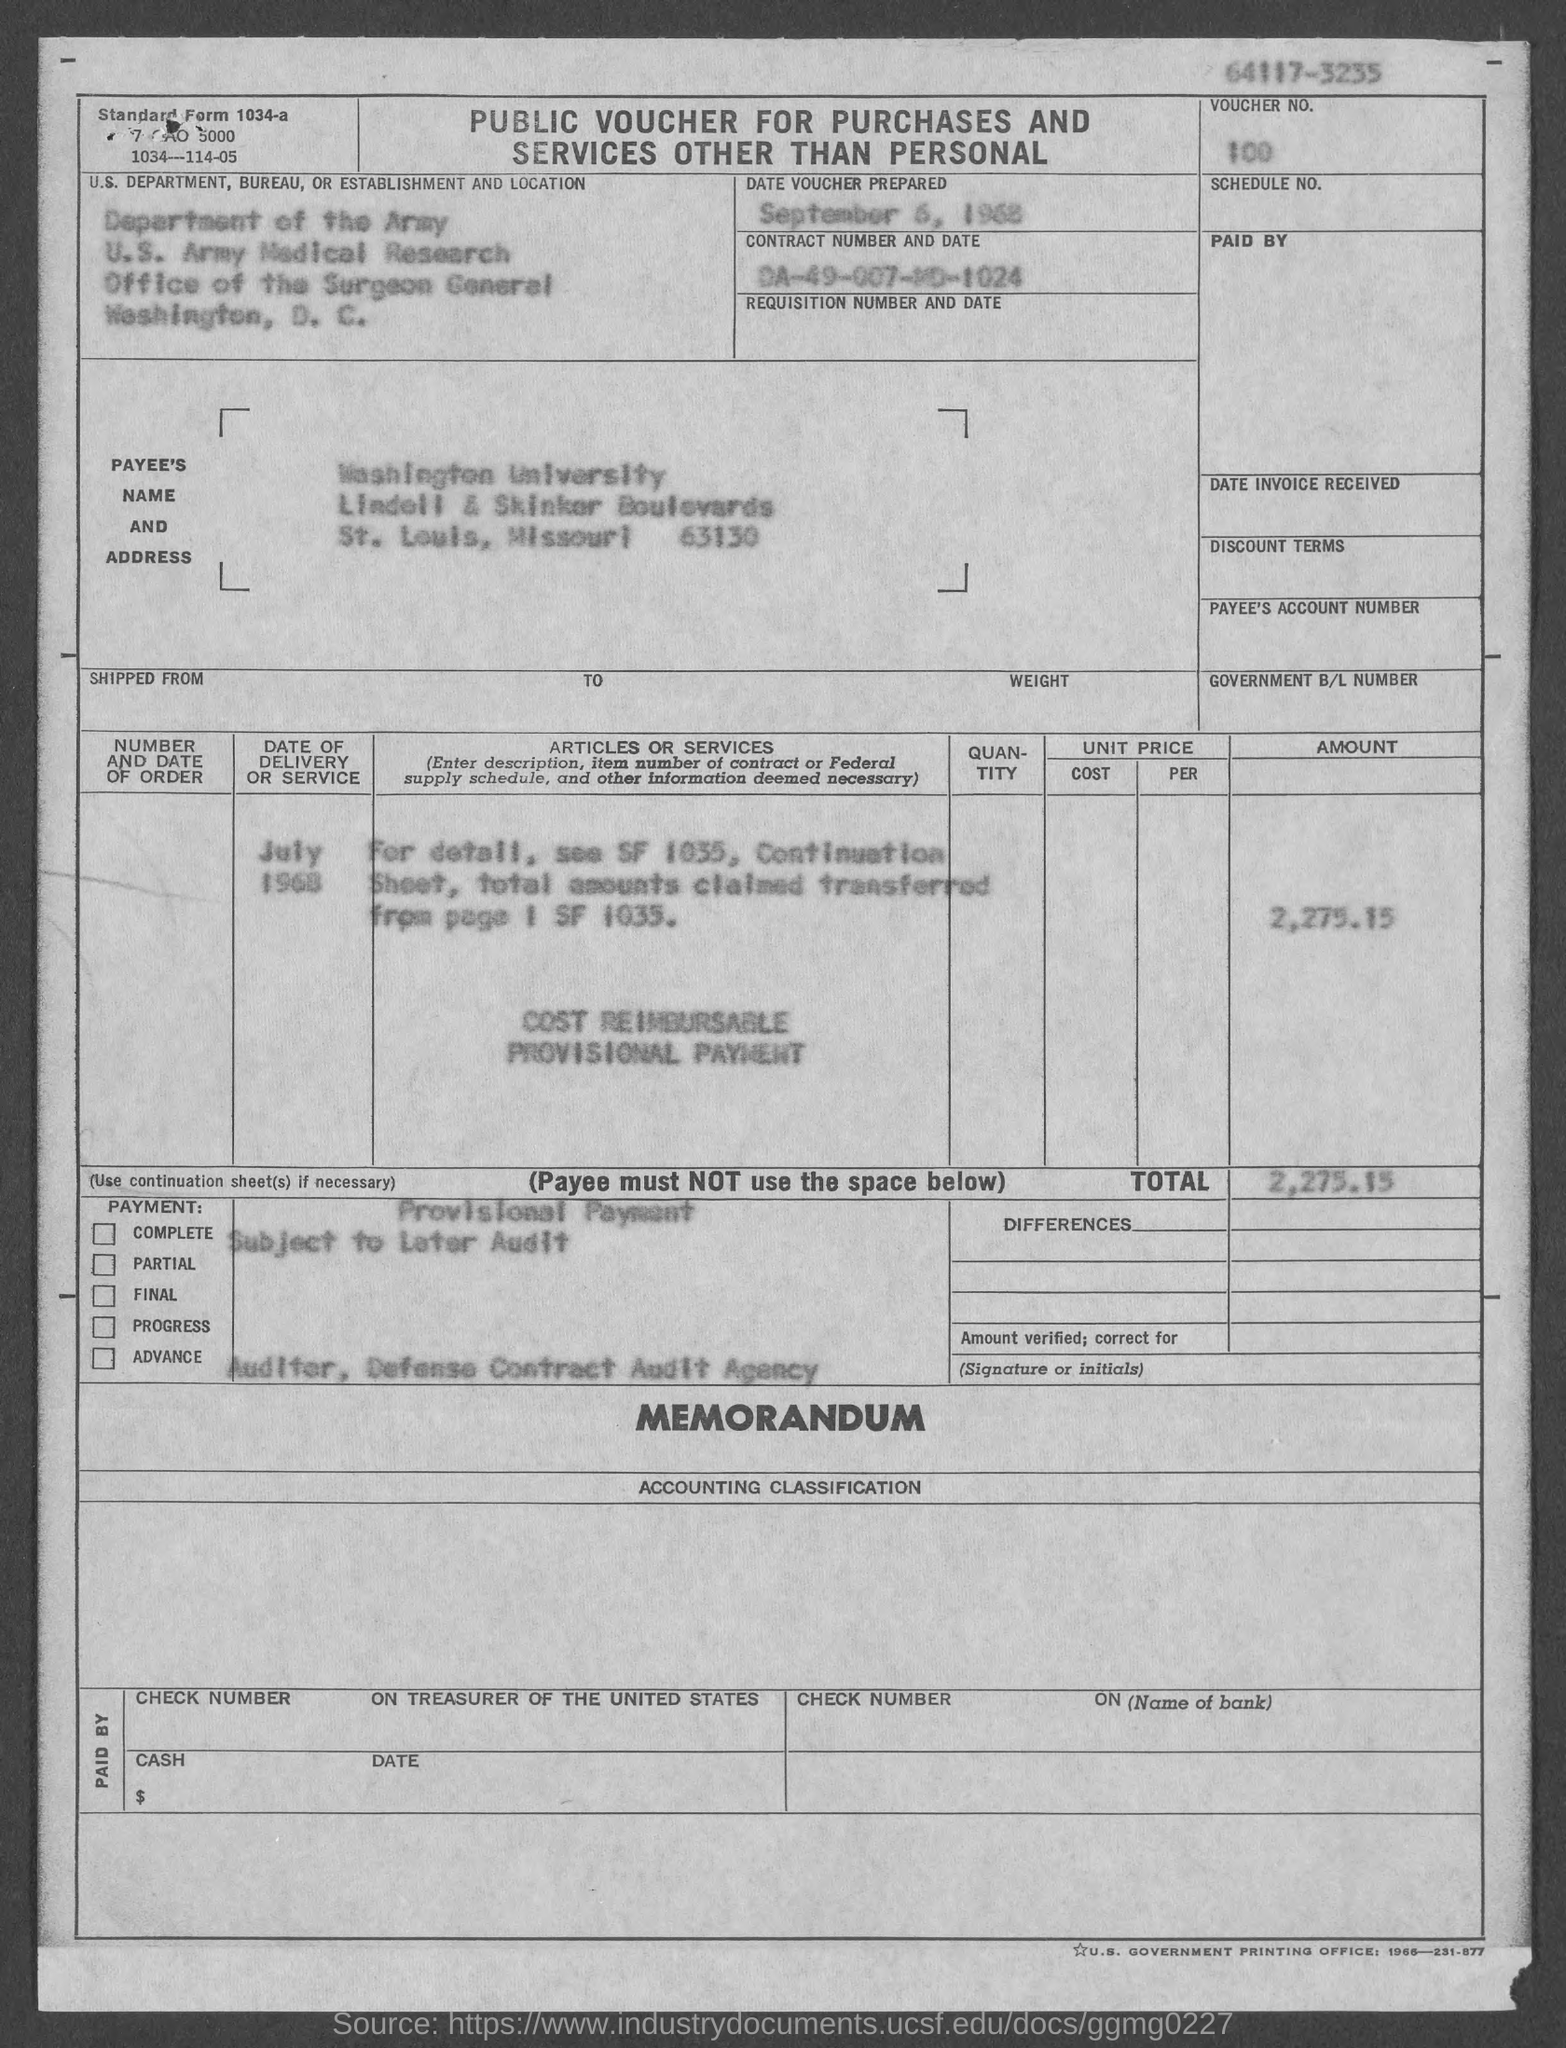Highlight a few significant elements in this photo. The total voucher amount is 2,275.15. On September 6, 1968, the date voucher was prepared. The payee's name is Washington University. The voucher number is 100... 